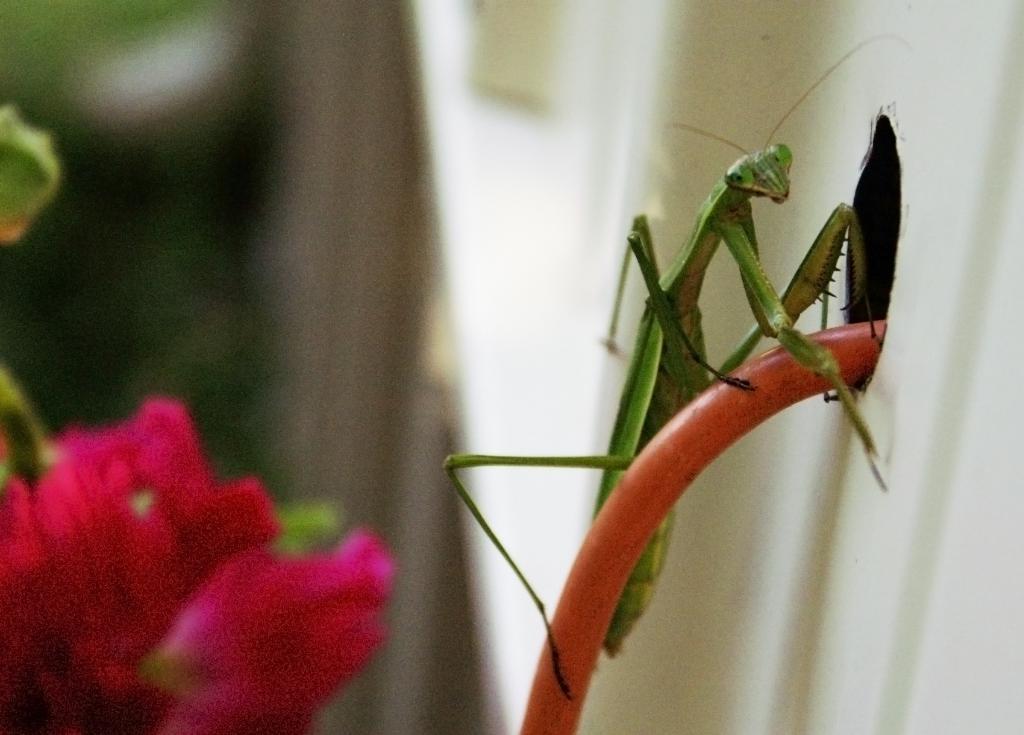How would you summarize this image in a sentence or two? In this image I can see a mantis which is green in color on a red colored wire and I can see a flower which is red in color and a white colored object and I can see the blurry background. 